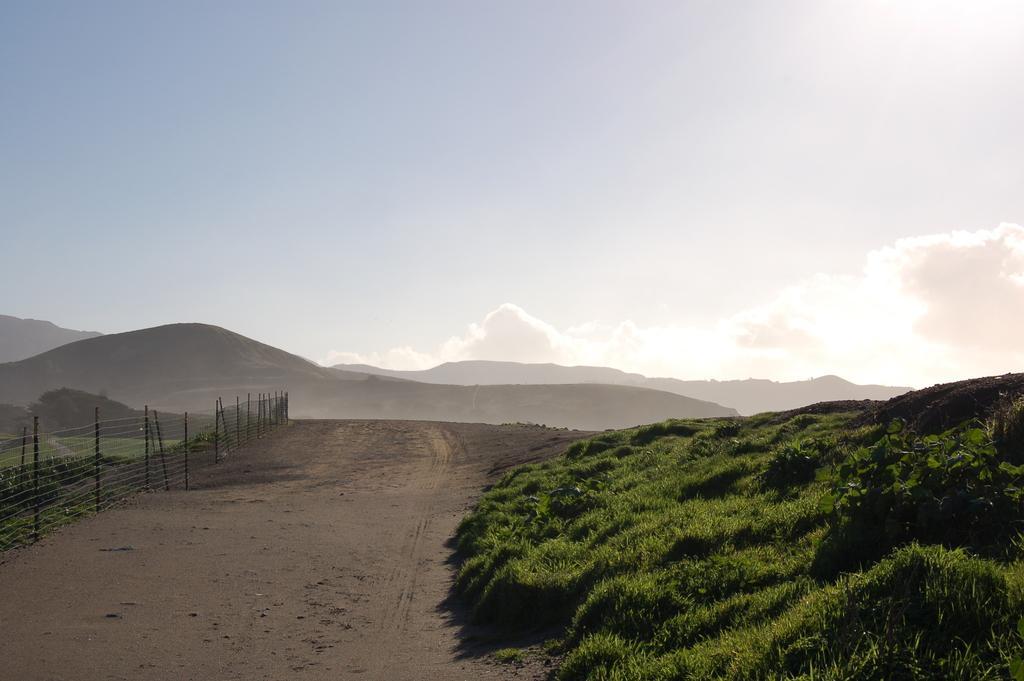In one or two sentences, can you explain what this image depicts? On the left side there is a road. On the right side I can see the grass. On the left side of the road there is a fencing. In the background there are few hills. At the top of the image I can see the sky and clouds. 